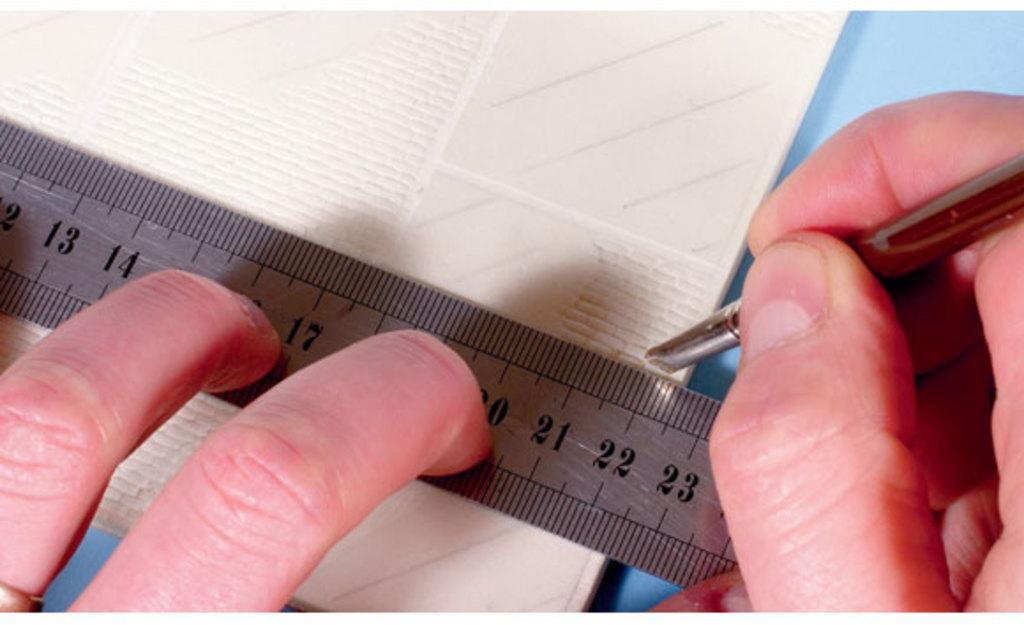Provide a one-sentence caption for the provided image. A person is holding a ruler and marking a point at about 22 centimeters. 